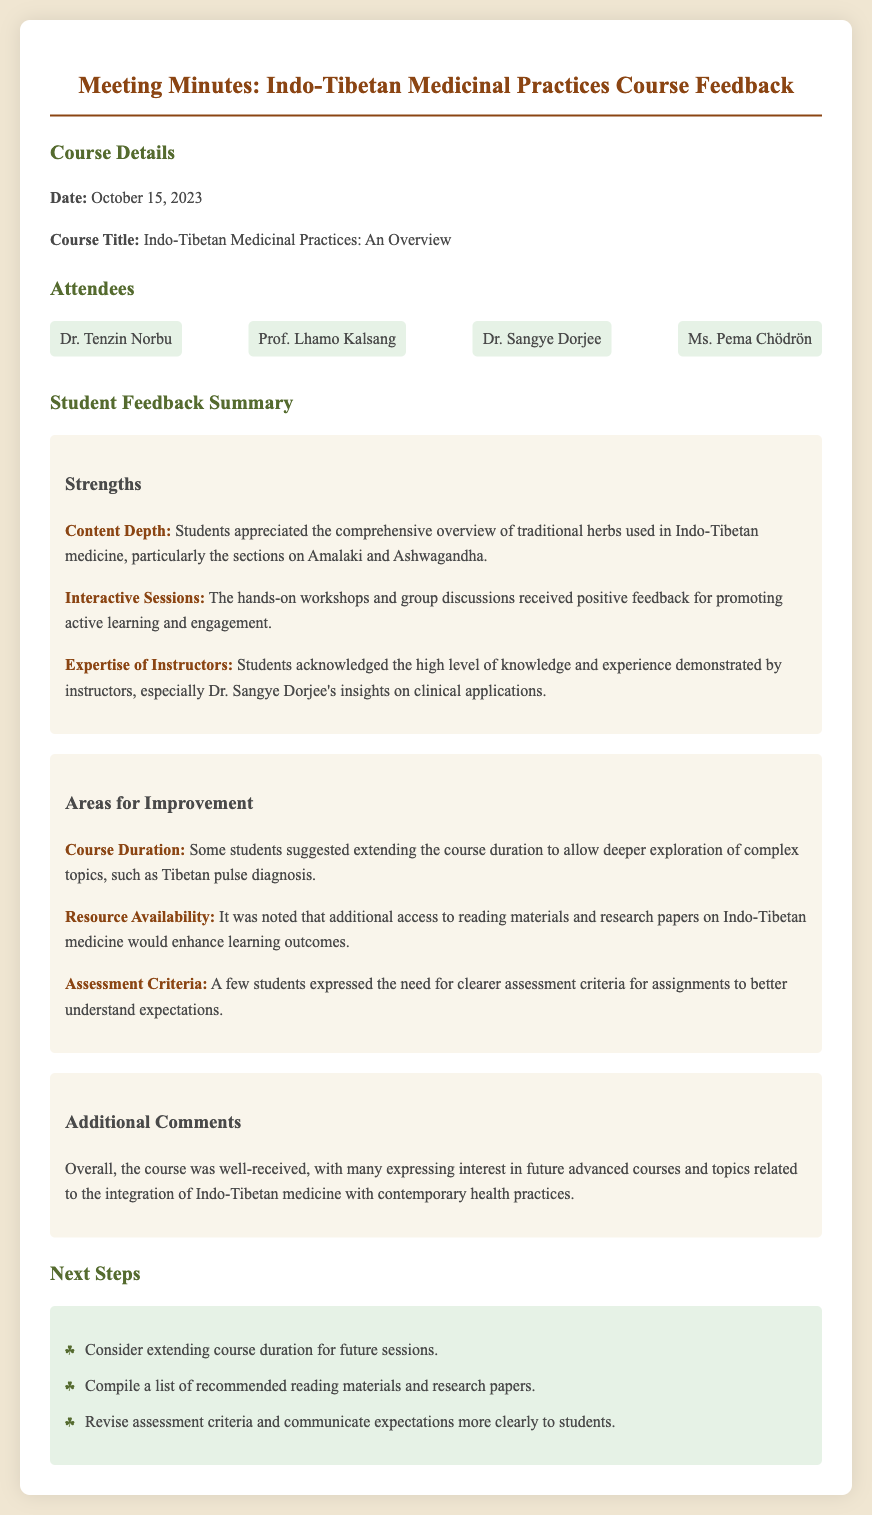what is the date of the meeting? The date of the meeting is specified in the document under "Course Details."
Answer: October 15, 2023 who is acknowledged for their insights on clinical applications? This information can be found under "Strengths" where students express appreciation for instructor expertise.
Answer: Dr. Sangye Dorjee what did students appreciate about the hands-on workshops? This is mentioned in the "Strengths" section where the feedback on workshops is discussed.
Answer: Promoting active learning and engagement which two herbs were highlighted for their comprehensive overview? The specific herbs are noted in the "Strengths" section regarding content depth.
Answer: Amalaki and Ashwagandha what area for improvement relates to resource availability? This information can be found in the "Areas for Improvement" section regarding student feedback.
Answer: Additional access to reading materials and research papers how many suggested extending the course duration? The document notes student feedback regarding the course duration under "Areas for Improvement," indicating some suggestions.
Answer: Some students what is one of the next steps identified in the meeting? The "Next Steps" section outlines actions to be taken based on the feedback.
Answer: Compile a list of recommended reading materials and research papers what did students express interest in for future courses? This is mentioned in the "Additional Comments" section of the feedback.
Answer: Future advanced courses and topics related to the integration of Indo-Tibetan medicine with contemporary health practices 